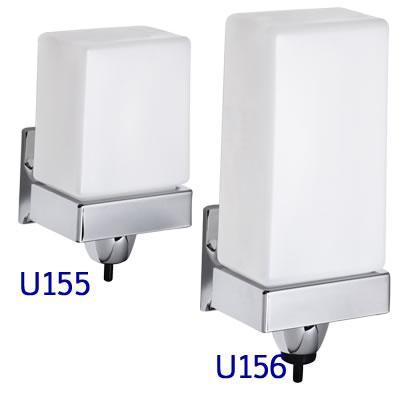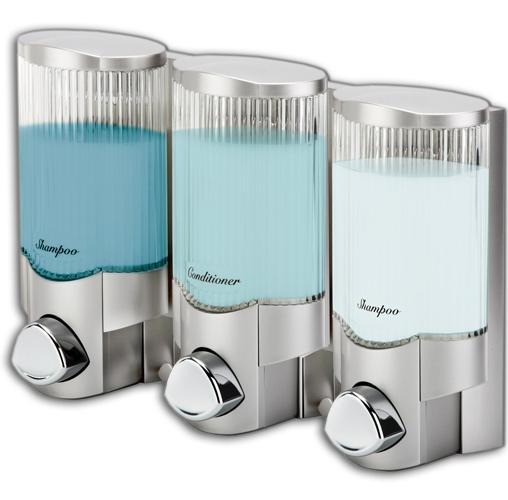The first image is the image on the left, the second image is the image on the right. Examine the images to the left and right. Is the description "An image shows exactly three side-by-side dispensers." accurate? Answer yes or no. Yes. The first image is the image on the left, the second image is the image on the right. Considering the images on both sides, is "1 of the images has 3 dispensers lined up in a row." valid? Answer yes or no. Yes. 